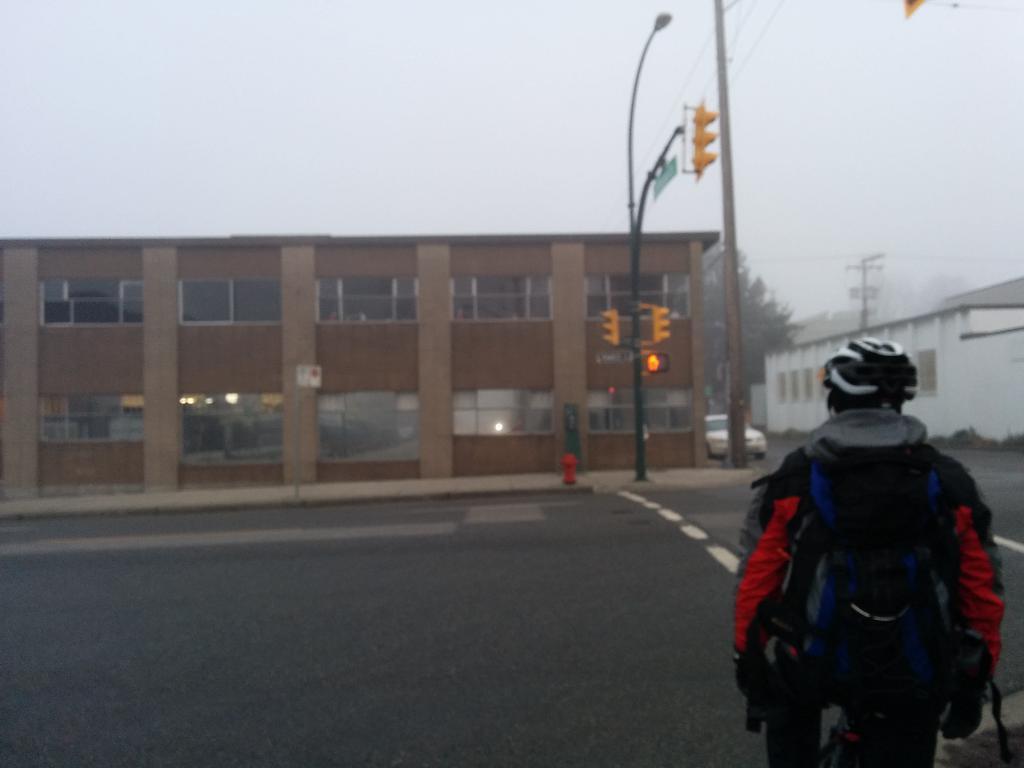Please provide a concise description of this image. In this image, I can see a person standing with a helmet. There are buildings, traffic lights, current pole and a vehicle on the road. In the background, I can see a tree and there is the sky. 